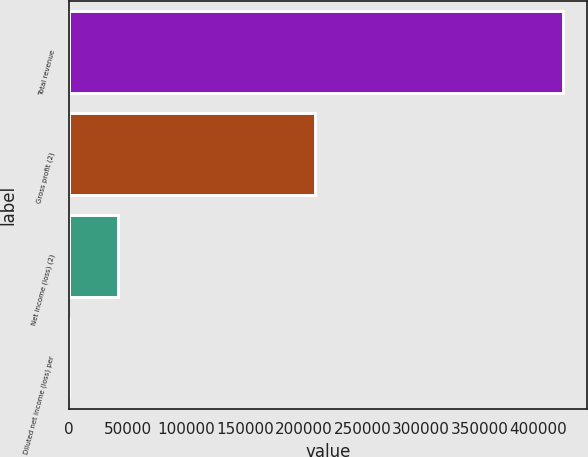Convert chart. <chart><loc_0><loc_0><loc_500><loc_500><bar_chart><fcel>Total revenue<fcel>Gross profit (2)<fcel>Net income (loss) (2)<fcel>Diluted net income (loss) per<nl><fcel>420693<fcel>209889<fcel>42069.4<fcel>0.1<nl></chart> 